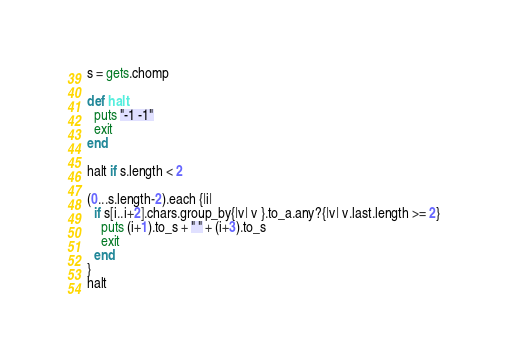Convert code to text. <code><loc_0><loc_0><loc_500><loc_500><_Ruby_>s = gets.chomp

def halt
  puts "-1 -1"
  exit
end

halt if s.length < 2

(0...s.length-2).each {|i|
  if s[i..i+2].chars.group_by{|v| v }.to_a.any?{|v| v.last.length >= 2}
    puts (i+1).to_s + " " + (i+3).to_s
    exit
  end
}
halt
</code> 